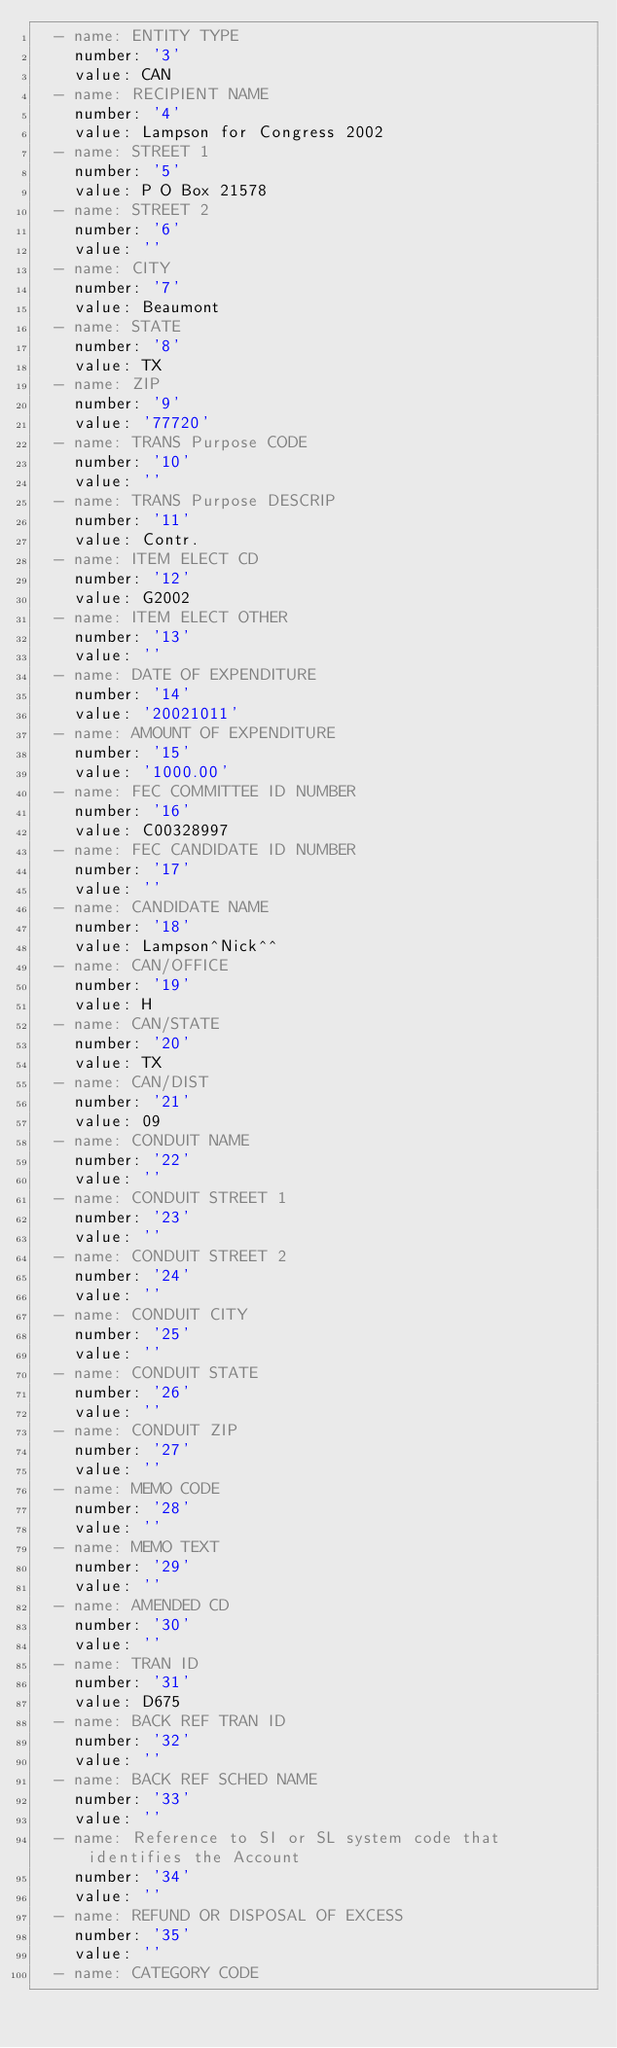<code> <loc_0><loc_0><loc_500><loc_500><_YAML_>  - name: ENTITY TYPE
    number: '3'
    value: CAN
  - name: RECIPIENT NAME
    number: '4'
    value: Lampson for Congress 2002
  - name: STREET 1
    number: '5'
    value: P O Box 21578
  - name: STREET 2
    number: '6'
    value: ''
  - name: CITY
    number: '7'
    value: Beaumont
  - name: STATE
    number: '8'
    value: TX
  - name: ZIP
    number: '9'
    value: '77720'
  - name: TRANS Purpose CODE
    number: '10'
    value: ''
  - name: TRANS Purpose DESCRIP
    number: '11'
    value: Contr.
  - name: ITEM ELECT CD
    number: '12'
    value: G2002
  - name: ITEM ELECT OTHER
    number: '13'
    value: ''
  - name: DATE OF EXPENDITURE
    number: '14'
    value: '20021011'
  - name: AMOUNT OF EXPENDITURE
    number: '15'
    value: '1000.00'
  - name: FEC COMMITTEE ID NUMBER
    number: '16'
    value: C00328997
  - name: FEC CANDIDATE ID NUMBER
    number: '17'
    value: ''
  - name: CANDIDATE NAME
    number: '18'
    value: Lampson^Nick^^
  - name: CAN/OFFICE
    number: '19'
    value: H
  - name: CAN/STATE
    number: '20'
    value: TX
  - name: CAN/DIST
    number: '21'
    value: 09
  - name: CONDUIT NAME
    number: '22'
    value: ''
  - name: CONDUIT STREET 1
    number: '23'
    value: ''
  - name: CONDUIT STREET 2
    number: '24'
    value: ''
  - name: CONDUIT CITY
    number: '25'
    value: ''
  - name: CONDUIT STATE
    number: '26'
    value: ''
  - name: CONDUIT ZIP
    number: '27'
    value: ''
  - name: MEMO CODE
    number: '28'
    value: ''
  - name: MEMO TEXT
    number: '29'
    value: ''
  - name: AMENDED CD
    number: '30'
    value: ''
  - name: TRAN ID
    number: '31'
    value: D675
  - name: BACK REF TRAN ID
    number: '32'
    value: ''
  - name: BACK REF SCHED NAME
    number: '33'
    value: ''
  - name: Reference to SI or SL system code that identifies the Account
    number: '34'
    value: ''
  - name: REFUND OR DISPOSAL OF EXCESS
    number: '35'
    value: ''
  - name: CATEGORY CODE</code> 